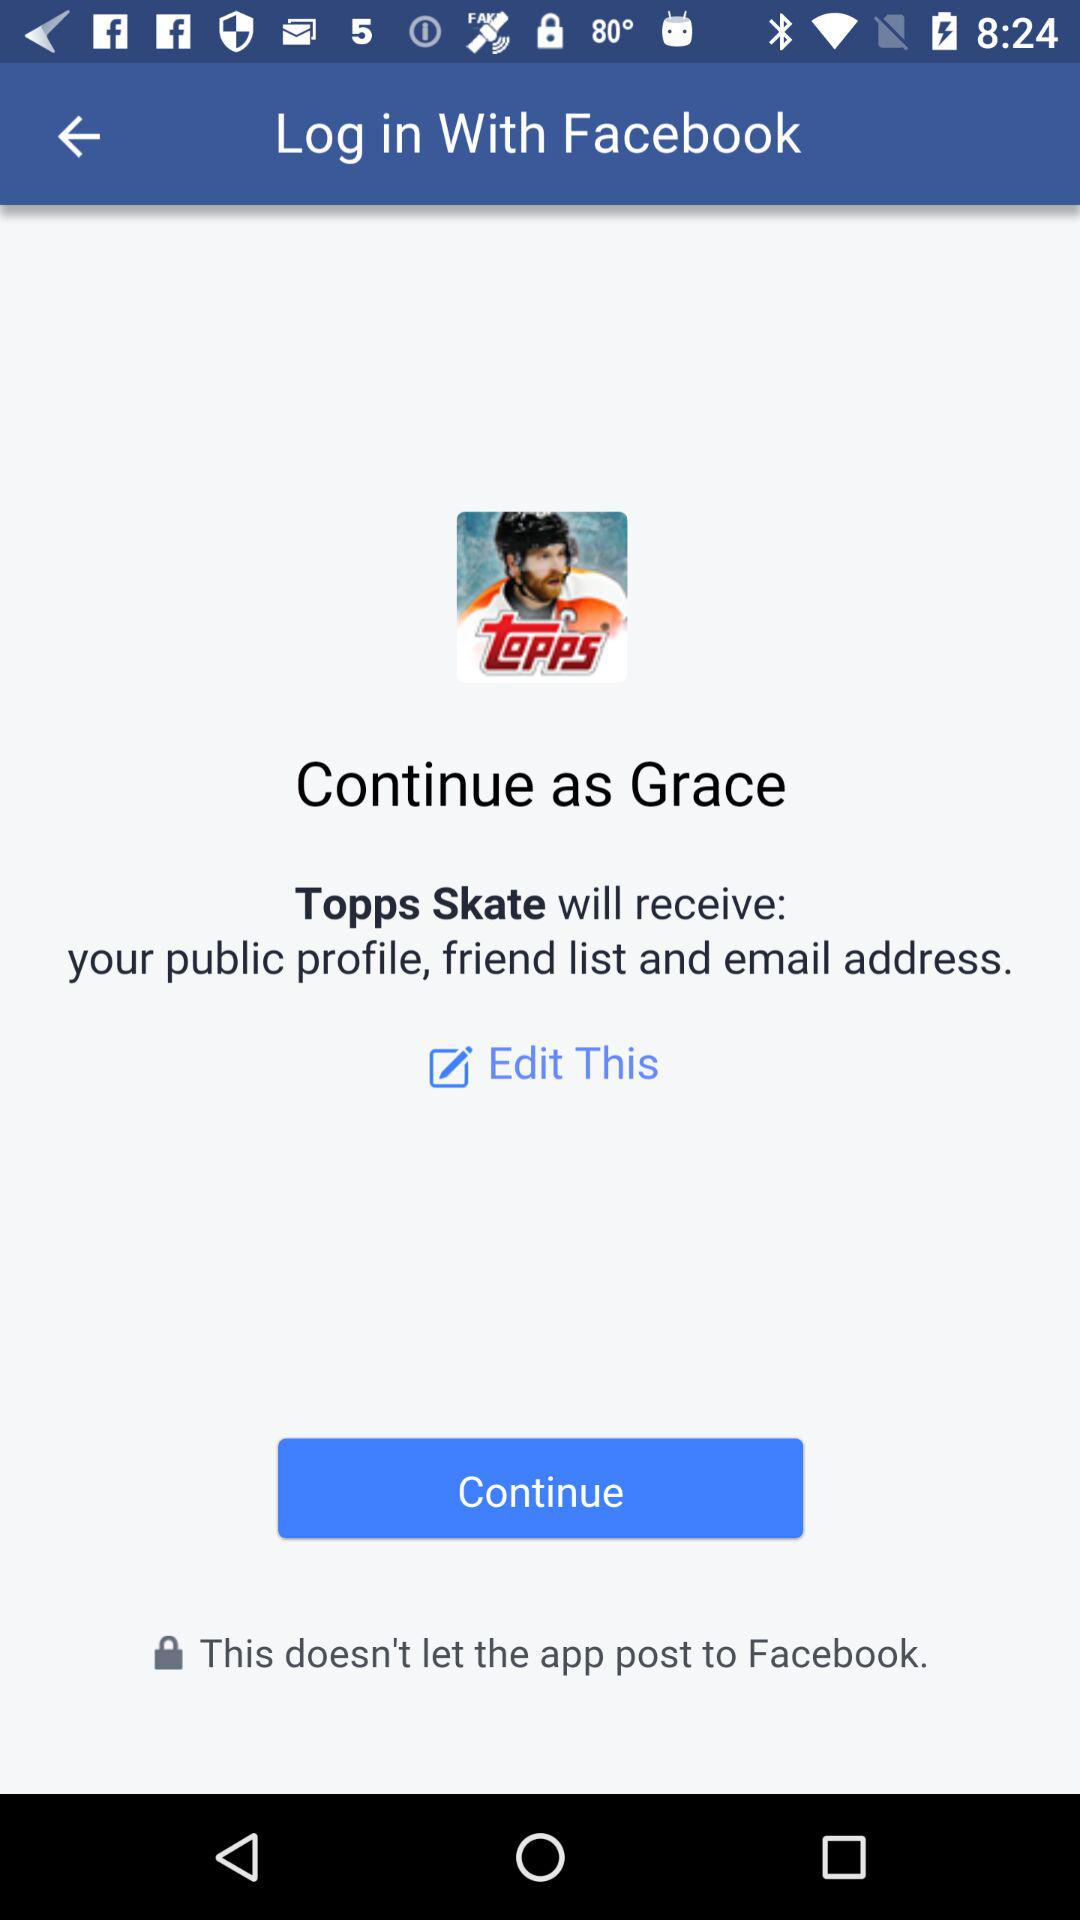What is the name of the user? The name of the user is Grace. 